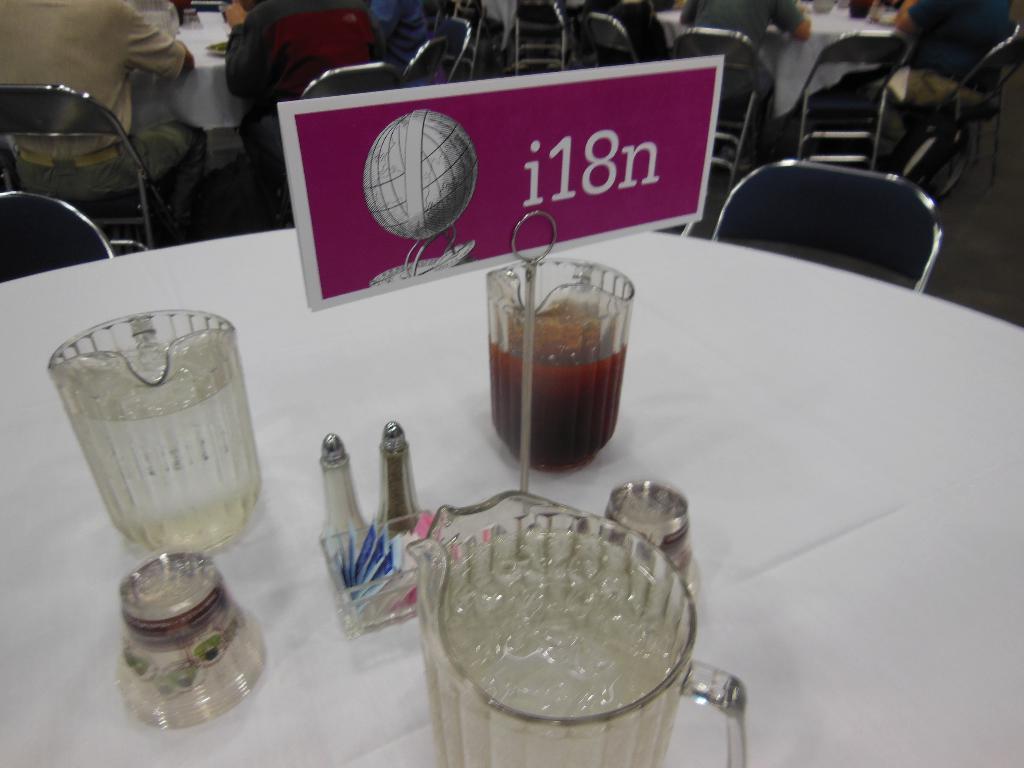What is the designation of the table?
Offer a terse response. I18n. 